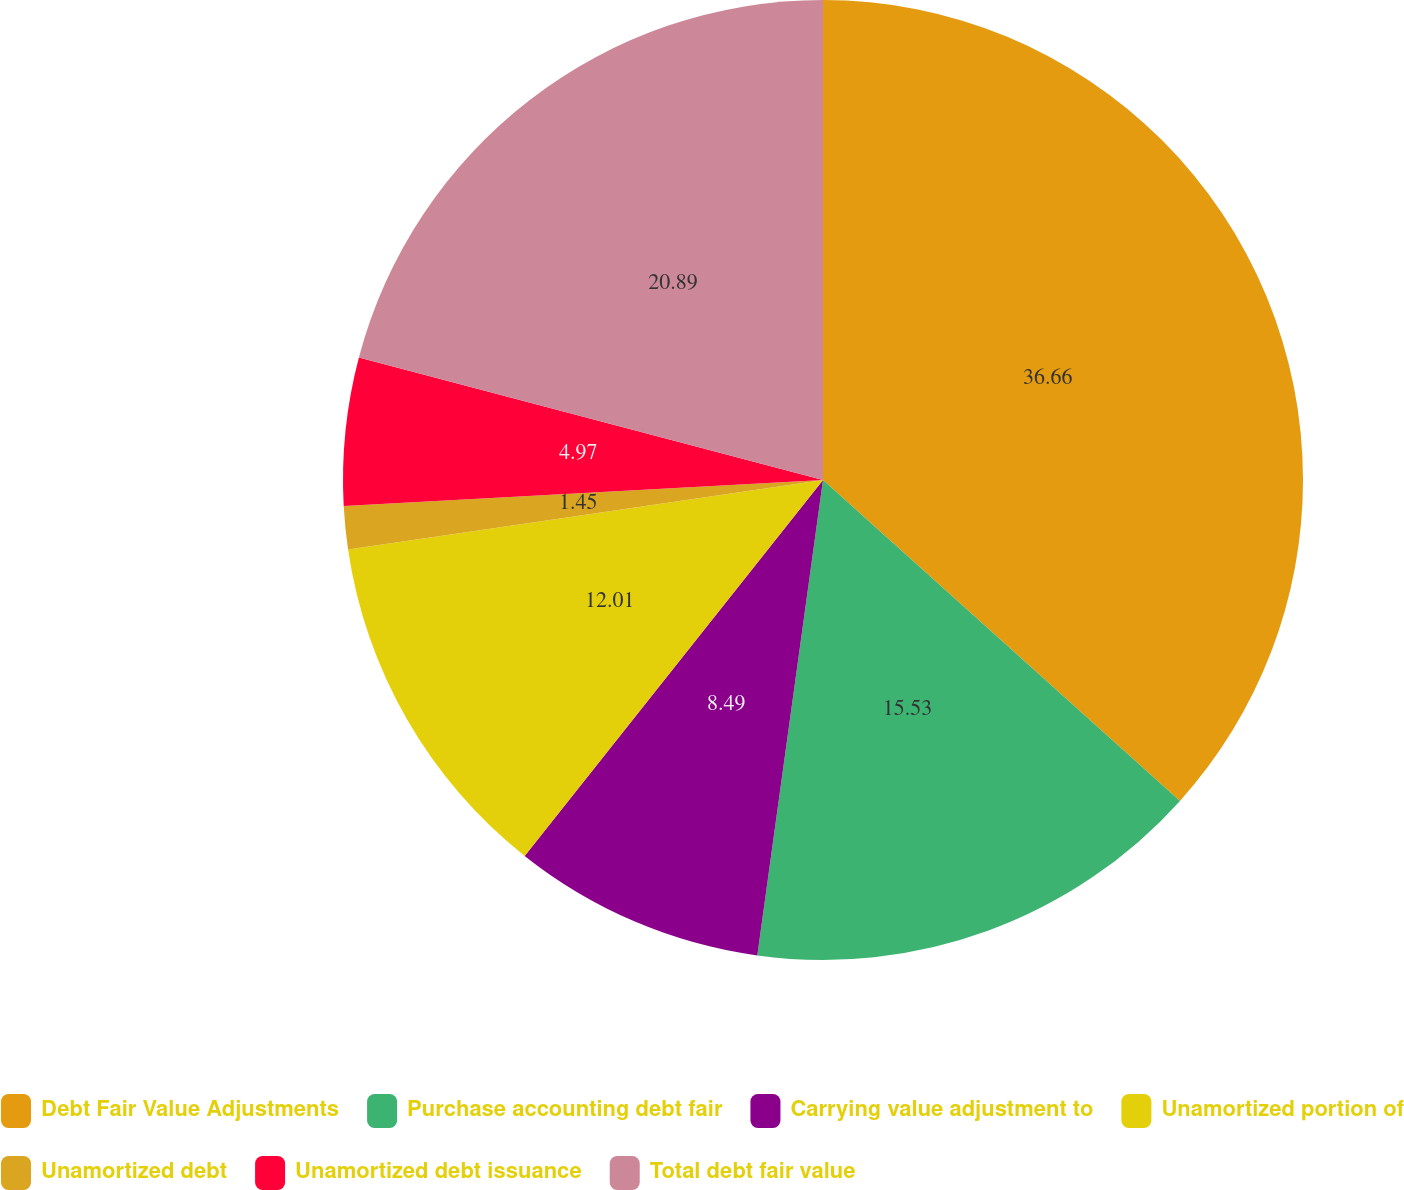<chart> <loc_0><loc_0><loc_500><loc_500><pie_chart><fcel>Debt Fair Value Adjustments<fcel>Purchase accounting debt fair<fcel>Carrying value adjustment to<fcel>Unamortized portion of<fcel>Unamortized debt<fcel>Unamortized debt issuance<fcel>Total debt fair value<nl><fcel>36.65%<fcel>15.53%<fcel>8.49%<fcel>12.01%<fcel>1.45%<fcel>4.97%<fcel>20.89%<nl></chart> 